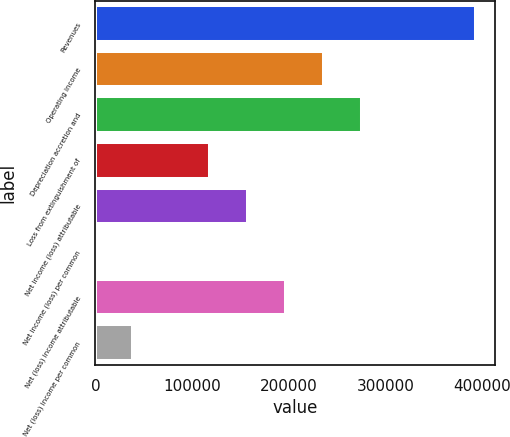<chart> <loc_0><loc_0><loc_500><loc_500><bar_chart><fcel>Revenues<fcel>Operating income<fcel>Depreciation accretion and<fcel>Loss from extinguishment of<fcel>Net income (loss) attributable<fcel>Net income (loss) per common<fcel>Net (loss) income attributable<fcel>Net (loss) income per common<nl><fcel>393293<fcel>235976<fcel>275305<fcel>117988<fcel>157317<fcel>0.13<fcel>196647<fcel>39329.4<nl></chart> 